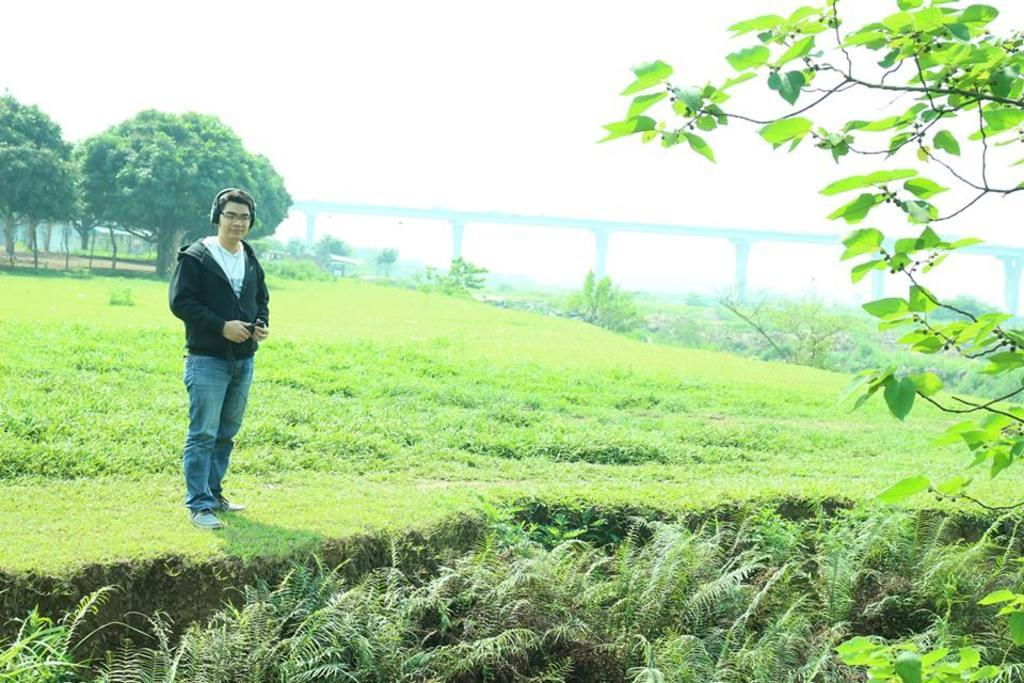What is the person in the image doing? The person is standing on the ground and holding an object. What can be seen in the background of the image? There are trees, a building, and a bridge visible in the background. What type of terrain is present in the image? There is grass in the image. What is visible in the sky in the image? The sky is visible in the image. What type of cracker is being used for payment in the image? There is no cracker or payment transaction present in the image. What stage of development is the building in the image? The image does not provide information about the development stage of the building. 